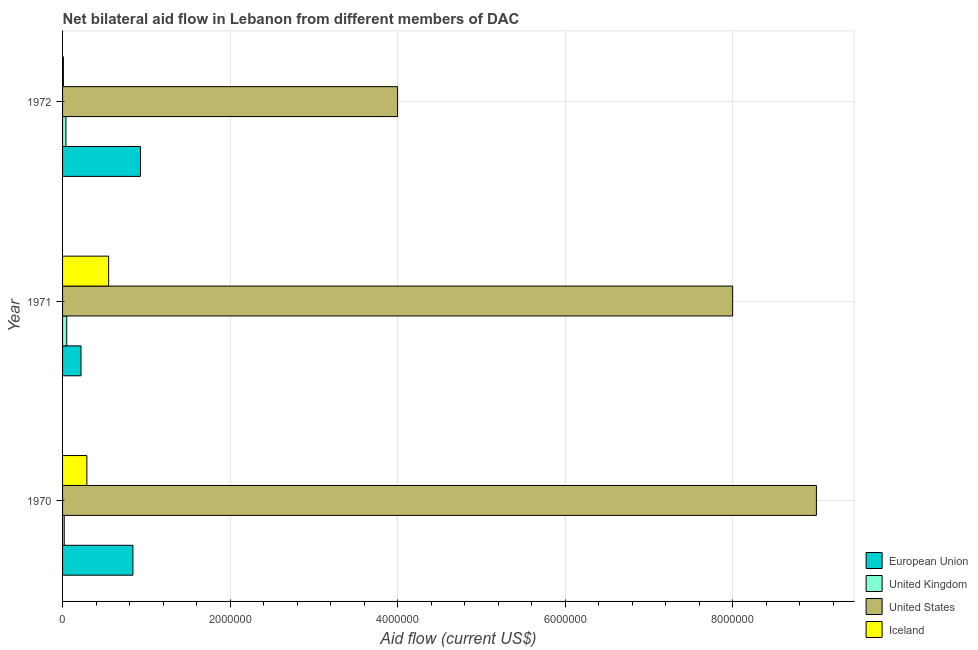How many groups of bars are there?
Ensure brevity in your answer.  3. Are the number of bars per tick equal to the number of legend labels?
Your answer should be compact. Yes. How many bars are there on the 3rd tick from the bottom?
Make the answer very short. 4. What is the label of the 1st group of bars from the top?
Keep it short and to the point. 1972. What is the amount of aid given by uk in 1970?
Provide a short and direct response. 2.00e+04. Across all years, what is the maximum amount of aid given by us?
Offer a very short reply. 9.00e+06. Across all years, what is the minimum amount of aid given by eu?
Provide a succinct answer. 2.20e+05. In which year was the amount of aid given by eu minimum?
Your answer should be compact. 1971. What is the total amount of aid given by us in the graph?
Offer a terse response. 2.10e+07. What is the difference between the amount of aid given by us in 1971 and that in 1972?
Keep it short and to the point. 4.00e+06. What is the difference between the amount of aid given by iceland in 1972 and the amount of aid given by uk in 1971?
Your answer should be compact. -4.00e+04. What is the average amount of aid given by uk per year?
Your response must be concise. 3.67e+04. In the year 1972, what is the difference between the amount of aid given by eu and amount of aid given by iceland?
Offer a very short reply. 9.20e+05. What is the ratio of the amount of aid given by uk in 1971 to that in 1972?
Offer a terse response. 1.25. Is the amount of aid given by eu in 1970 less than that in 1972?
Offer a very short reply. Yes. What is the difference between the highest and the lowest amount of aid given by us?
Make the answer very short. 5.00e+06. Is the sum of the amount of aid given by us in 1970 and 1971 greater than the maximum amount of aid given by uk across all years?
Provide a short and direct response. Yes. Is it the case that in every year, the sum of the amount of aid given by iceland and amount of aid given by us is greater than the sum of amount of aid given by uk and amount of aid given by eu?
Your answer should be compact. No. Is it the case that in every year, the sum of the amount of aid given by eu and amount of aid given by uk is greater than the amount of aid given by us?
Offer a terse response. No. How many bars are there?
Your answer should be very brief. 12. What is the difference between two consecutive major ticks on the X-axis?
Ensure brevity in your answer.  2.00e+06. Are the values on the major ticks of X-axis written in scientific E-notation?
Offer a very short reply. No. What is the title of the graph?
Give a very brief answer. Net bilateral aid flow in Lebanon from different members of DAC. Does "Budget management" appear as one of the legend labels in the graph?
Provide a succinct answer. No. What is the label or title of the X-axis?
Your answer should be compact. Aid flow (current US$). What is the Aid flow (current US$) of European Union in 1970?
Ensure brevity in your answer.  8.40e+05. What is the Aid flow (current US$) of United Kingdom in 1970?
Offer a very short reply. 2.00e+04. What is the Aid flow (current US$) of United States in 1970?
Give a very brief answer. 9.00e+06. What is the Aid flow (current US$) in United States in 1971?
Your answer should be compact. 8.00e+06. What is the Aid flow (current US$) in Iceland in 1971?
Offer a terse response. 5.50e+05. What is the Aid flow (current US$) of European Union in 1972?
Provide a succinct answer. 9.30e+05. What is the Aid flow (current US$) of United Kingdom in 1972?
Your answer should be compact. 4.00e+04. Across all years, what is the maximum Aid flow (current US$) in European Union?
Your answer should be very brief. 9.30e+05. Across all years, what is the maximum Aid flow (current US$) of United States?
Keep it short and to the point. 9.00e+06. Across all years, what is the minimum Aid flow (current US$) in United States?
Your answer should be compact. 4.00e+06. What is the total Aid flow (current US$) of European Union in the graph?
Your answer should be very brief. 1.99e+06. What is the total Aid flow (current US$) in United States in the graph?
Make the answer very short. 2.10e+07. What is the total Aid flow (current US$) of Iceland in the graph?
Ensure brevity in your answer.  8.50e+05. What is the difference between the Aid flow (current US$) in European Union in 1970 and that in 1971?
Offer a very short reply. 6.20e+05. What is the difference between the Aid flow (current US$) in United Kingdom in 1970 and that in 1971?
Offer a very short reply. -3.00e+04. What is the difference between the Aid flow (current US$) in Iceland in 1970 and that in 1971?
Give a very brief answer. -2.60e+05. What is the difference between the Aid flow (current US$) in United States in 1970 and that in 1972?
Your answer should be very brief. 5.00e+06. What is the difference between the Aid flow (current US$) in European Union in 1971 and that in 1972?
Give a very brief answer. -7.10e+05. What is the difference between the Aid flow (current US$) in United States in 1971 and that in 1972?
Ensure brevity in your answer.  4.00e+06. What is the difference between the Aid flow (current US$) in Iceland in 1971 and that in 1972?
Provide a short and direct response. 5.40e+05. What is the difference between the Aid flow (current US$) of European Union in 1970 and the Aid flow (current US$) of United Kingdom in 1971?
Keep it short and to the point. 7.90e+05. What is the difference between the Aid flow (current US$) in European Union in 1970 and the Aid flow (current US$) in United States in 1971?
Provide a succinct answer. -7.16e+06. What is the difference between the Aid flow (current US$) of European Union in 1970 and the Aid flow (current US$) of Iceland in 1971?
Your answer should be compact. 2.90e+05. What is the difference between the Aid flow (current US$) in United Kingdom in 1970 and the Aid flow (current US$) in United States in 1971?
Your response must be concise. -7.98e+06. What is the difference between the Aid flow (current US$) of United Kingdom in 1970 and the Aid flow (current US$) of Iceland in 1971?
Keep it short and to the point. -5.30e+05. What is the difference between the Aid flow (current US$) in United States in 1970 and the Aid flow (current US$) in Iceland in 1971?
Offer a very short reply. 8.45e+06. What is the difference between the Aid flow (current US$) of European Union in 1970 and the Aid flow (current US$) of United States in 1972?
Provide a succinct answer. -3.16e+06. What is the difference between the Aid flow (current US$) of European Union in 1970 and the Aid flow (current US$) of Iceland in 1972?
Provide a succinct answer. 8.30e+05. What is the difference between the Aid flow (current US$) of United Kingdom in 1970 and the Aid flow (current US$) of United States in 1972?
Your response must be concise. -3.98e+06. What is the difference between the Aid flow (current US$) in United Kingdom in 1970 and the Aid flow (current US$) in Iceland in 1972?
Offer a terse response. 10000. What is the difference between the Aid flow (current US$) of United States in 1970 and the Aid flow (current US$) of Iceland in 1972?
Keep it short and to the point. 8.99e+06. What is the difference between the Aid flow (current US$) of European Union in 1971 and the Aid flow (current US$) of United Kingdom in 1972?
Ensure brevity in your answer.  1.80e+05. What is the difference between the Aid flow (current US$) of European Union in 1971 and the Aid flow (current US$) of United States in 1972?
Offer a terse response. -3.78e+06. What is the difference between the Aid flow (current US$) of European Union in 1971 and the Aid flow (current US$) of Iceland in 1972?
Offer a very short reply. 2.10e+05. What is the difference between the Aid flow (current US$) in United Kingdom in 1971 and the Aid flow (current US$) in United States in 1972?
Provide a short and direct response. -3.95e+06. What is the difference between the Aid flow (current US$) in United Kingdom in 1971 and the Aid flow (current US$) in Iceland in 1972?
Keep it short and to the point. 4.00e+04. What is the difference between the Aid flow (current US$) of United States in 1971 and the Aid flow (current US$) of Iceland in 1972?
Your response must be concise. 7.99e+06. What is the average Aid flow (current US$) in European Union per year?
Keep it short and to the point. 6.63e+05. What is the average Aid flow (current US$) in United Kingdom per year?
Your response must be concise. 3.67e+04. What is the average Aid flow (current US$) in Iceland per year?
Offer a terse response. 2.83e+05. In the year 1970, what is the difference between the Aid flow (current US$) in European Union and Aid flow (current US$) in United Kingdom?
Offer a terse response. 8.20e+05. In the year 1970, what is the difference between the Aid flow (current US$) of European Union and Aid flow (current US$) of United States?
Make the answer very short. -8.16e+06. In the year 1970, what is the difference between the Aid flow (current US$) in European Union and Aid flow (current US$) in Iceland?
Provide a short and direct response. 5.50e+05. In the year 1970, what is the difference between the Aid flow (current US$) of United Kingdom and Aid flow (current US$) of United States?
Your answer should be very brief. -8.98e+06. In the year 1970, what is the difference between the Aid flow (current US$) in United Kingdom and Aid flow (current US$) in Iceland?
Offer a terse response. -2.70e+05. In the year 1970, what is the difference between the Aid flow (current US$) in United States and Aid flow (current US$) in Iceland?
Your response must be concise. 8.71e+06. In the year 1971, what is the difference between the Aid flow (current US$) of European Union and Aid flow (current US$) of United States?
Your response must be concise. -7.78e+06. In the year 1971, what is the difference between the Aid flow (current US$) of European Union and Aid flow (current US$) of Iceland?
Make the answer very short. -3.30e+05. In the year 1971, what is the difference between the Aid flow (current US$) of United Kingdom and Aid flow (current US$) of United States?
Your response must be concise. -7.95e+06. In the year 1971, what is the difference between the Aid flow (current US$) of United Kingdom and Aid flow (current US$) of Iceland?
Make the answer very short. -5.00e+05. In the year 1971, what is the difference between the Aid flow (current US$) of United States and Aid flow (current US$) of Iceland?
Your response must be concise. 7.45e+06. In the year 1972, what is the difference between the Aid flow (current US$) in European Union and Aid flow (current US$) in United Kingdom?
Give a very brief answer. 8.90e+05. In the year 1972, what is the difference between the Aid flow (current US$) in European Union and Aid flow (current US$) in United States?
Ensure brevity in your answer.  -3.07e+06. In the year 1972, what is the difference between the Aid flow (current US$) in European Union and Aid flow (current US$) in Iceland?
Your answer should be very brief. 9.20e+05. In the year 1972, what is the difference between the Aid flow (current US$) in United Kingdom and Aid flow (current US$) in United States?
Make the answer very short. -3.96e+06. In the year 1972, what is the difference between the Aid flow (current US$) of United States and Aid flow (current US$) of Iceland?
Your answer should be compact. 3.99e+06. What is the ratio of the Aid flow (current US$) of European Union in 1970 to that in 1971?
Provide a succinct answer. 3.82. What is the ratio of the Aid flow (current US$) in Iceland in 1970 to that in 1971?
Your answer should be very brief. 0.53. What is the ratio of the Aid flow (current US$) in European Union in 1970 to that in 1972?
Keep it short and to the point. 0.9. What is the ratio of the Aid flow (current US$) of United States in 1970 to that in 1972?
Give a very brief answer. 2.25. What is the ratio of the Aid flow (current US$) of Iceland in 1970 to that in 1972?
Offer a terse response. 29. What is the ratio of the Aid flow (current US$) of European Union in 1971 to that in 1972?
Provide a succinct answer. 0.24. What is the ratio of the Aid flow (current US$) of United Kingdom in 1971 to that in 1972?
Keep it short and to the point. 1.25. What is the ratio of the Aid flow (current US$) in United States in 1971 to that in 1972?
Your answer should be very brief. 2. What is the difference between the highest and the second highest Aid flow (current US$) in European Union?
Your answer should be compact. 9.00e+04. What is the difference between the highest and the second highest Aid flow (current US$) in United Kingdom?
Offer a very short reply. 10000. What is the difference between the highest and the second highest Aid flow (current US$) of United States?
Your answer should be compact. 1.00e+06. What is the difference between the highest and the lowest Aid flow (current US$) in European Union?
Make the answer very short. 7.10e+05. What is the difference between the highest and the lowest Aid flow (current US$) in United Kingdom?
Offer a terse response. 3.00e+04. What is the difference between the highest and the lowest Aid flow (current US$) of Iceland?
Make the answer very short. 5.40e+05. 